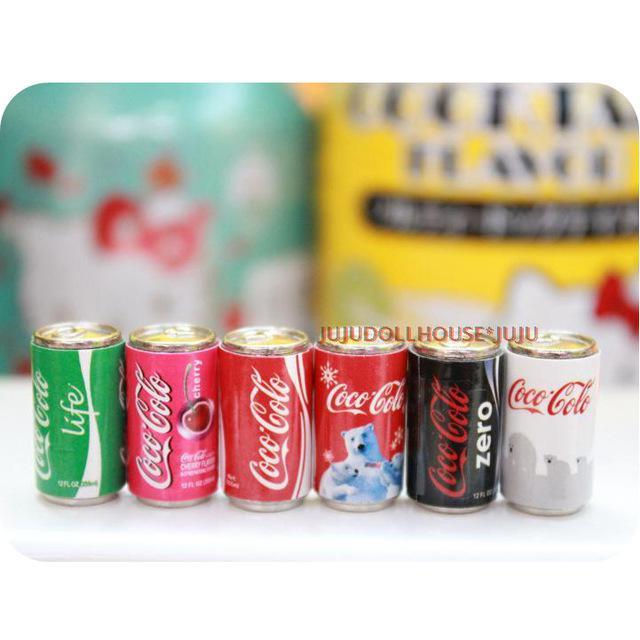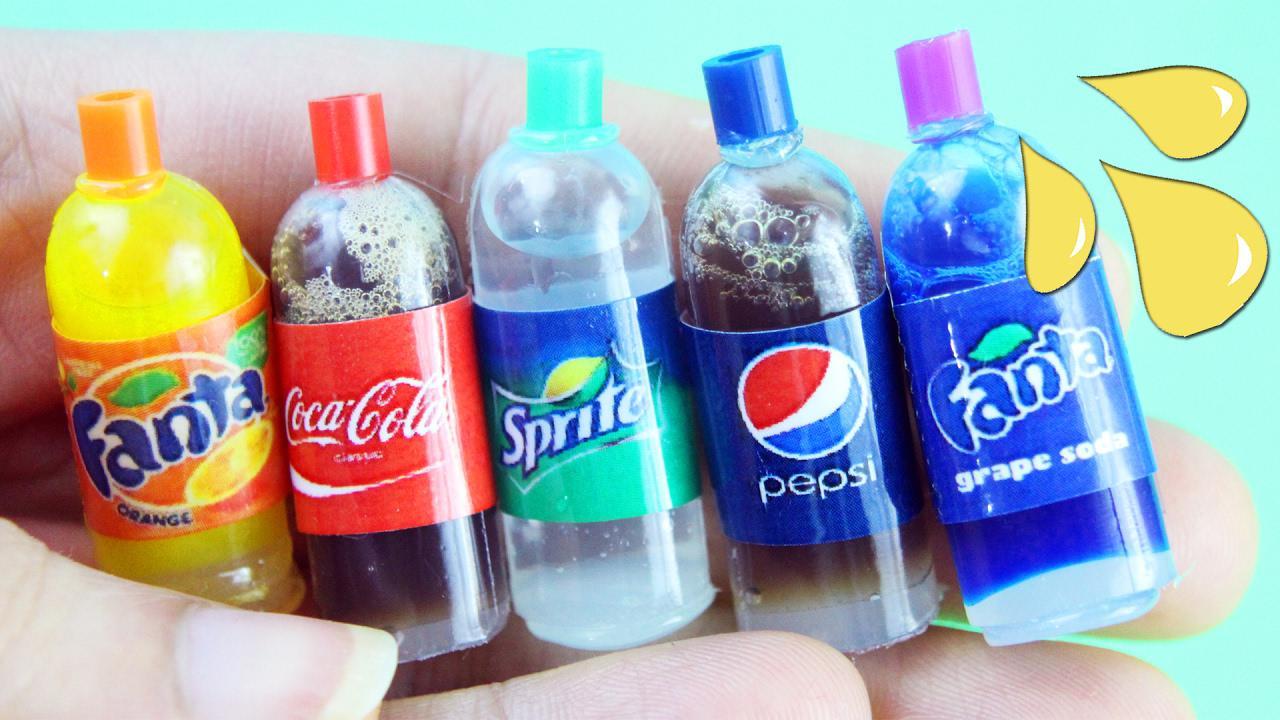The first image is the image on the left, the second image is the image on the right. For the images displayed, is the sentence "The left image contains at least three cans of soda." factually correct? Answer yes or no. Yes. 